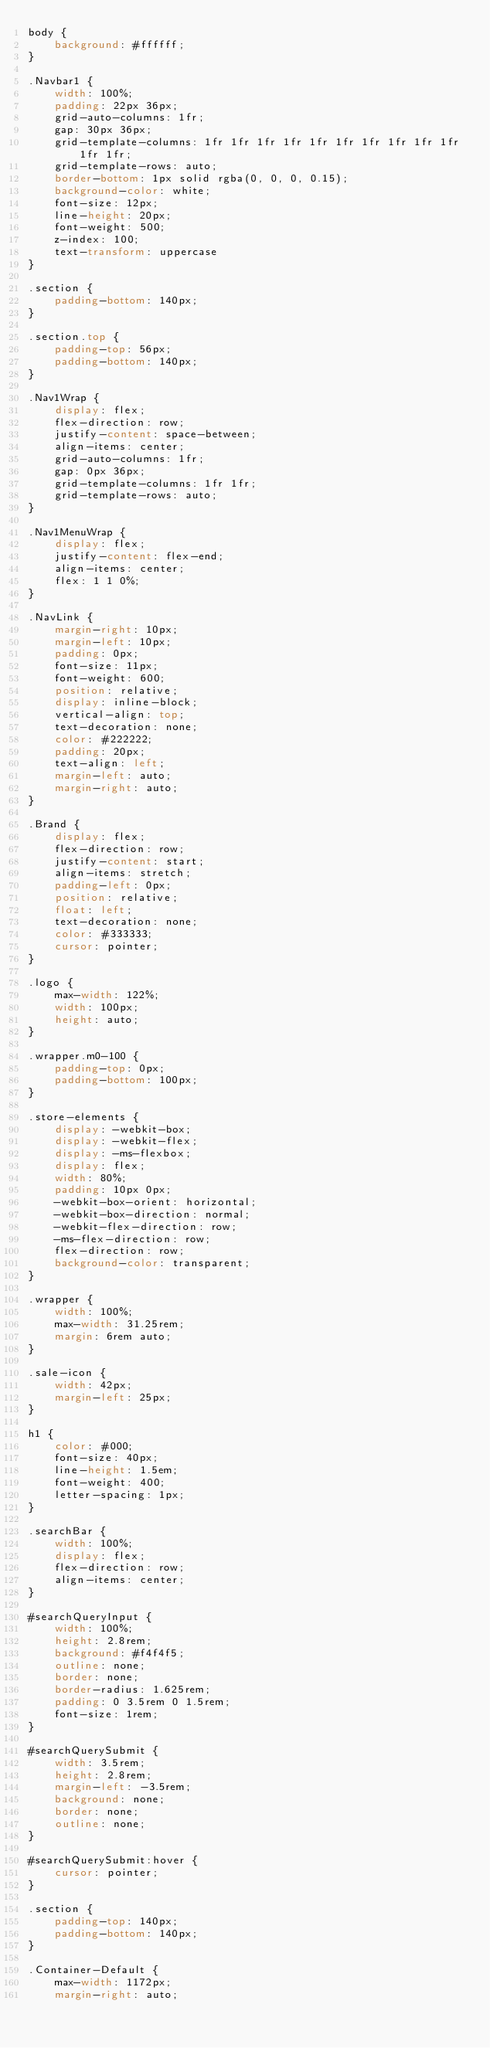Convert code to text. <code><loc_0><loc_0><loc_500><loc_500><_CSS_>body {
    background: #ffffff;
}

.Navbar1 {
    width: 100%;
    padding: 22px 36px;
    grid-auto-columns: 1fr;
    gap: 30px 36px;
    grid-template-columns: 1fr 1fr 1fr 1fr 1fr 1fr 1fr 1fr 1fr 1fr 1fr 1fr;
    grid-template-rows: auto;
    border-bottom: 1px solid rgba(0, 0, 0, 0.15);
    background-color: white;
    font-size: 12px;
    line-height: 20px;
    font-weight: 500;
    z-index: 100;
    text-transform: uppercase
}

.section {
    padding-bottom: 140px;
}

.section.top {
    padding-top: 56px;
    padding-bottom: 140px;
}

.Nav1Wrap {
    display: flex;
    flex-direction: row;
    justify-content: space-between;
    align-items: center;
    grid-auto-columns: 1fr;
    gap: 0px 36px;
    grid-template-columns: 1fr 1fr;
    grid-template-rows: auto;
}

.Nav1MenuWrap {
    display: flex;
    justify-content: flex-end;
    align-items: center;
    flex: 1 1 0%;
}

.NavLink {
    margin-right: 10px;
    margin-left: 10px;
    padding: 0px;
    font-size: 11px;
    font-weight: 600;
    position: relative;
    display: inline-block;
    vertical-align: top;
    text-decoration: none;
    color: #222222;
    padding: 20px;
    text-align: left;
    margin-left: auto;
    margin-right: auto;
}

.Brand {
    display: flex;
    flex-direction: row;
    justify-content: start;
    align-items: stretch;
    padding-left: 0px;
    position: relative;
    float: left;
    text-decoration: none;
    color: #333333;
    cursor: pointer;
}

.logo {
    max-width: 122%;
    width: 100px;
    height: auto;
}

.wrapper.m0-100 {
    padding-top: 0px;
    padding-bottom: 100px;
}

.store-elements {
    display: -webkit-box;
    display: -webkit-flex;
    display: -ms-flexbox;
    display: flex;
    width: 80%;
    padding: 10px 0px;
    -webkit-box-orient: horizontal;
    -webkit-box-direction: normal;
    -webkit-flex-direction: row;
    -ms-flex-direction: row;
    flex-direction: row;
    background-color: transparent;
}

.wrapper {
    width: 100%;
    max-width: 31.25rem;
    margin: 6rem auto;
}

.sale-icon {
    width: 42px;
    margin-left: 25px;
}

h1 {
    color: #000;
    font-size: 40px;
    line-height: 1.5em;
    font-weight: 400;
    letter-spacing: 1px;
}

.searchBar {
    width: 100%;
    display: flex;
    flex-direction: row;
    align-items: center;
}

#searchQueryInput {
    width: 100%;
    height: 2.8rem;
    background: #f4f4f5;
    outline: none;
    border: none;
    border-radius: 1.625rem;
    padding: 0 3.5rem 0 1.5rem;
    font-size: 1rem;
}

#searchQuerySubmit {
    width: 3.5rem;
    height: 2.8rem;
    margin-left: -3.5rem;
    background: none;
    border: none;
    outline: none;
}

#searchQuerySubmit:hover {
    cursor: pointer;
}

.section {
    padding-top: 140px;
    padding-bottom: 140px;
}

.Container-Default {
    max-width: 1172px;
    margin-right: auto;</code> 